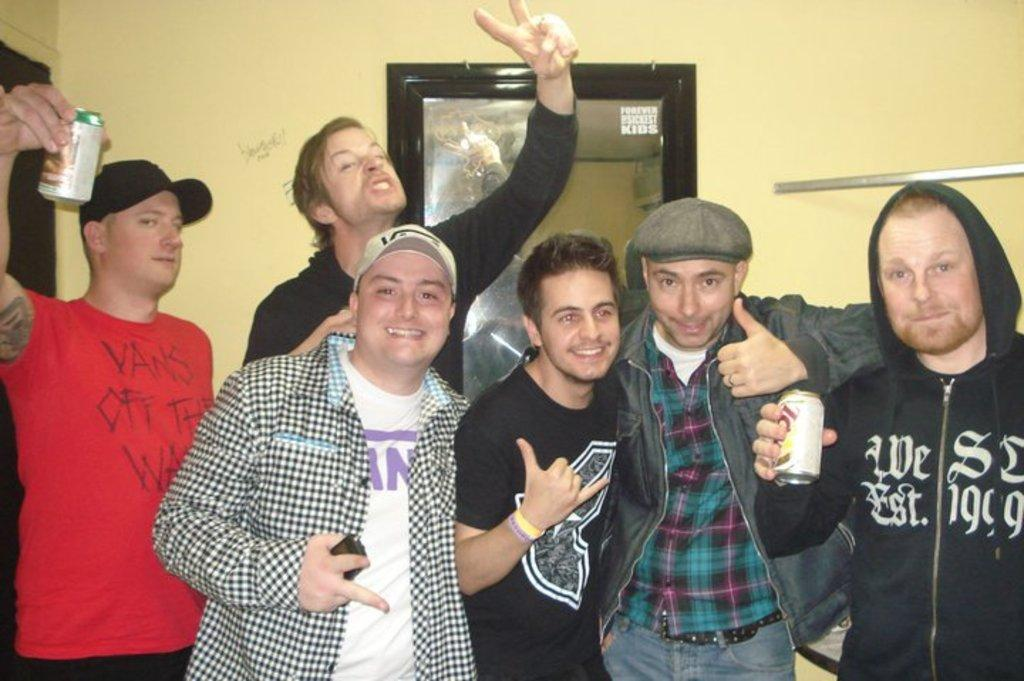<image>
Give a short and clear explanation of the subsequent image. Six friends pose together, and two of them are wearing Vans shirts. 